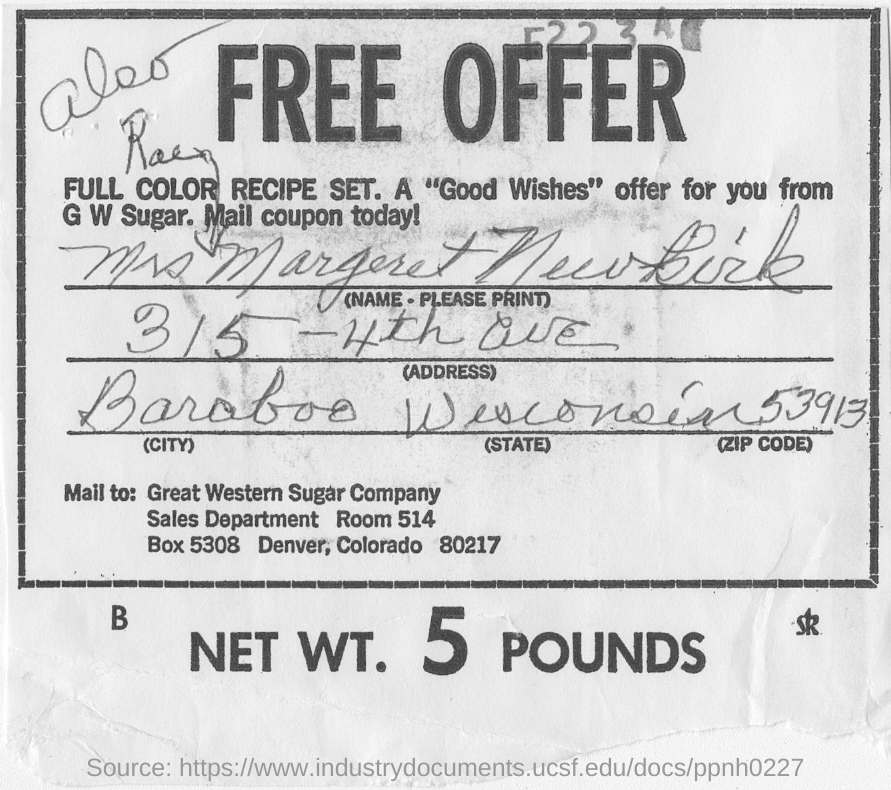What is the NET WT.?
Make the answer very short. 5 POUNDS. What is the zip code of colorado?
Offer a terse response. 80217. 